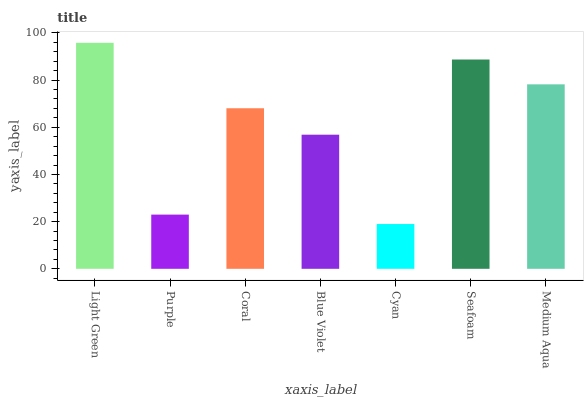Is Cyan the minimum?
Answer yes or no. Yes. Is Light Green the maximum?
Answer yes or no. Yes. Is Purple the minimum?
Answer yes or no. No. Is Purple the maximum?
Answer yes or no. No. Is Light Green greater than Purple?
Answer yes or no. Yes. Is Purple less than Light Green?
Answer yes or no. Yes. Is Purple greater than Light Green?
Answer yes or no. No. Is Light Green less than Purple?
Answer yes or no. No. Is Coral the high median?
Answer yes or no. Yes. Is Coral the low median?
Answer yes or no. Yes. Is Light Green the high median?
Answer yes or no. No. Is Seafoam the low median?
Answer yes or no. No. 